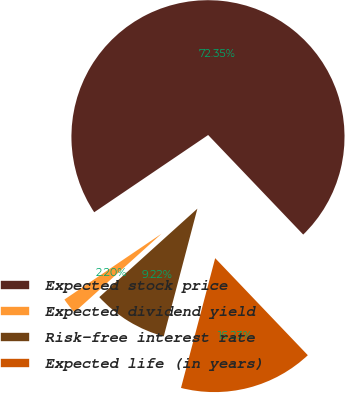Convert chart to OTSL. <chart><loc_0><loc_0><loc_500><loc_500><pie_chart><fcel>Expected stock price<fcel>Expected dividend yield<fcel>Risk-free interest rate<fcel>Expected life (in years)<nl><fcel>72.35%<fcel>2.2%<fcel>9.22%<fcel>16.23%<nl></chart> 